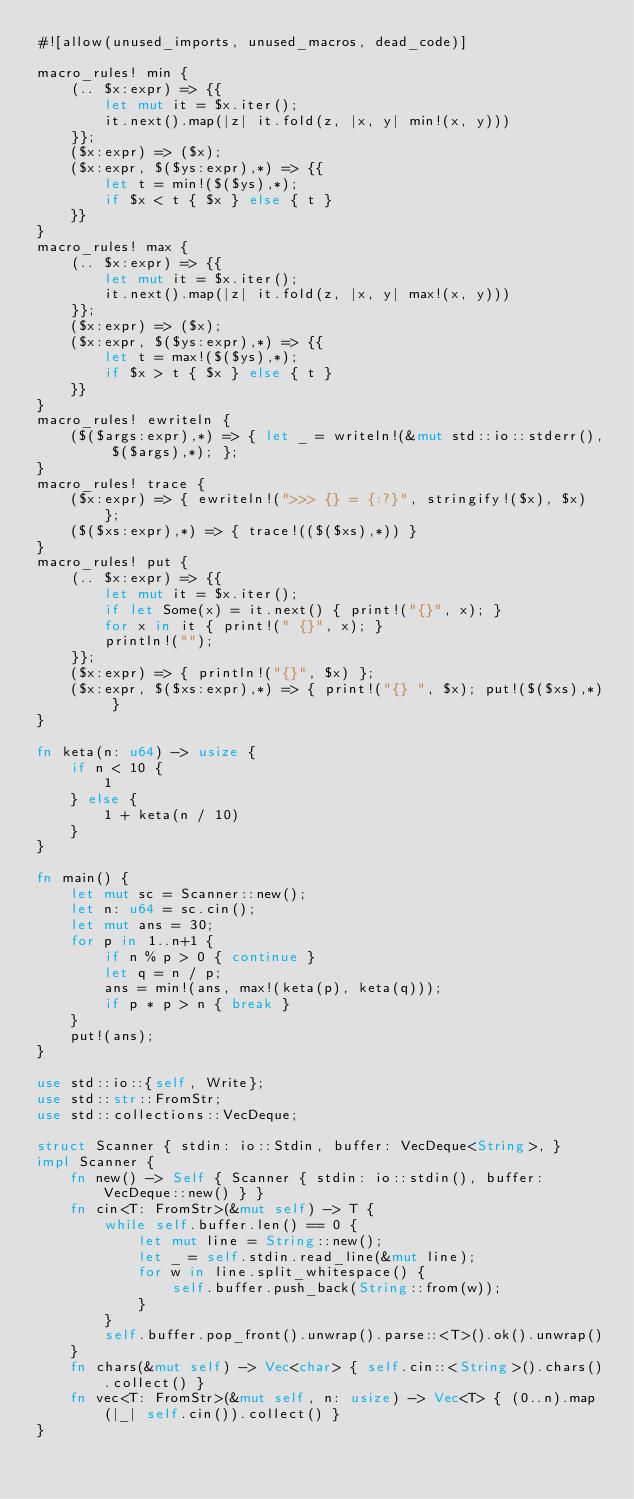<code> <loc_0><loc_0><loc_500><loc_500><_Rust_>#![allow(unused_imports, unused_macros, dead_code)]

macro_rules! min {
    (.. $x:expr) => {{
        let mut it = $x.iter();
        it.next().map(|z| it.fold(z, |x, y| min!(x, y)))
    }};
    ($x:expr) => ($x);
    ($x:expr, $($ys:expr),*) => {{
        let t = min!($($ys),*);
        if $x < t { $x } else { t }
    }}
}
macro_rules! max {
    (.. $x:expr) => {{
        let mut it = $x.iter();
        it.next().map(|z| it.fold(z, |x, y| max!(x, y)))
    }};
    ($x:expr) => ($x);
    ($x:expr, $($ys:expr),*) => {{
        let t = max!($($ys),*);
        if $x > t { $x } else { t }
    }}
}
macro_rules! ewriteln {
    ($($args:expr),*) => { let _ = writeln!(&mut std::io::stderr(), $($args),*); };
}
macro_rules! trace {
    ($x:expr) => { ewriteln!(">>> {} = {:?}", stringify!($x), $x) };
    ($($xs:expr),*) => { trace!(($($xs),*)) }
}
macro_rules! put {
    (.. $x:expr) => {{
        let mut it = $x.iter();
        if let Some(x) = it.next() { print!("{}", x); }
        for x in it { print!(" {}", x); }
        println!("");
    }};
    ($x:expr) => { println!("{}", $x) };
    ($x:expr, $($xs:expr),*) => { print!("{} ", $x); put!($($xs),*) }
}

fn keta(n: u64) -> usize {
    if n < 10 {
        1
    } else {
        1 + keta(n / 10)
    }
}

fn main() {
    let mut sc = Scanner::new();
    let n: u64 = sc.cin();
    let mut ans = 30;
    for p in 1..n+1 {
        if n % p > 0 { continue }
        let q = n / p;
        ans = min!(ans, max!(keta(p), keta(q)));
        if p * p > n { break }
    }
    put!(ans);
}

use std::io::{self, Write};
use std::str::FromStr;
use std::collections::VecDeque;

struct Scanner { stdin: io::Stdin, buffer: VecDeque<String>, }
impl Scanner {
    fn new() -> Self { Scanner { stdin: io::stdin(), buffer: VecDeque::new() } }
    fn cin<T: FromStr>(&mut self) -> T {
        while self.buffer.len() == 0 {
            let mut line = String::new();
            let _ = self.stdin.read_line(&mut line);
            for w in line.split_whitespace() {
                self.buffer.push_back(String::from(w));
            }
        }
        self.buffer.pop_front().unwrap().parse::<T>().ok().unwrap()
    }
    fn chars(&mut self) -> Vec<char> { self.cin::<String>().chars().collect() }
    fn vec<T: FromStr>(&mut self, n: usize) -> Vec<T> { (0..n).map(|_| self.cin()).collect() }
}
</code> 